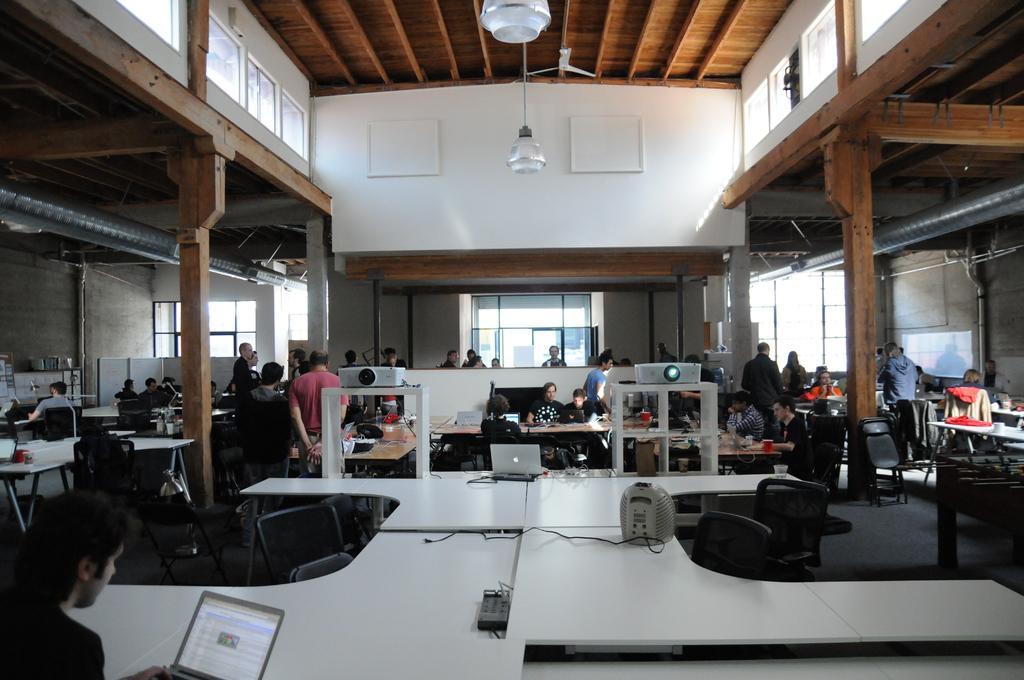How would you summarize this image in a sentence or two? In this picture I can see the inside view of a building, there are group of people sitting on the chairs, there are group of people standing, there are laptops and some other objects on the tables, there are lights, fan, and in the background there are windows. 